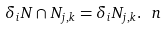Convert formula to latex. <formula><loc_0><loc_0><loc_500><loc_500>\delta _ { i } N \cap N _ { j , k } = \delta _ { i } N _ { j , k } . \ n</formula> 